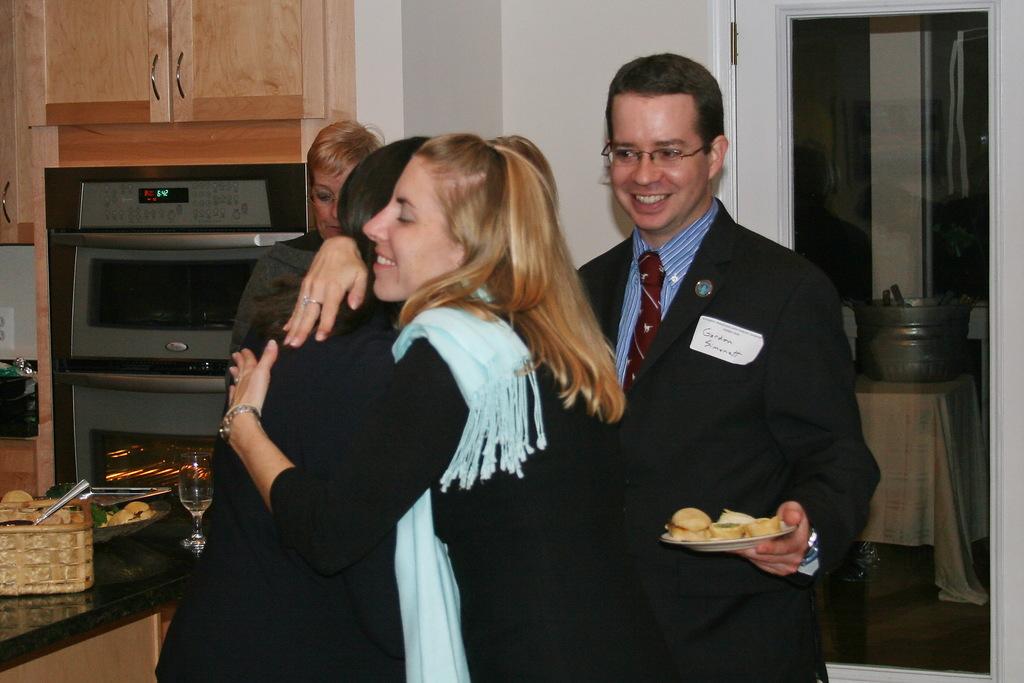Who is watching them hug?
Keep it short and to the point. Gordon simonett. What time is on the oven?
Your response must be concise. 6:42. 